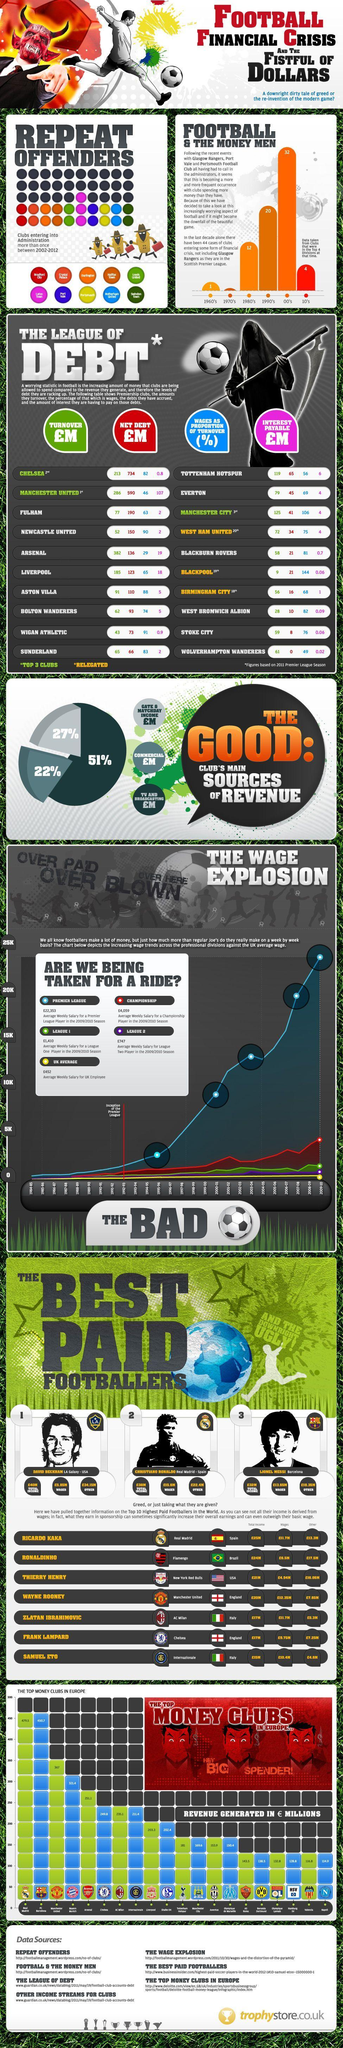Which footballer had the highest total income Christiano Ronaldo, Lionel Messi, or David Beckham?
Answer the question with a short phrase. David Beckham What is the difference in the average weekly salary of a League 1 in comparison to average weekly salary for a UK employee? 958 Who is the best paid footballer in FCB ? Lionel Messi Which category of football players are the highest paid? Premier League Which team is the highest repeat offender? Luton town How many teams were relegated? 3 How many clubs share the least amount of revenue generated in millions pounds? 6 Which contributes as the least source of income commercial, gate & matchday, or TV & broadcasting? COMMERCIAL What is the name of the player listed in the fifth row? Zlatan Ibrahimovic Which player earned revenue from other sources to an amount of 4.8 pound million? Samuel Eto 